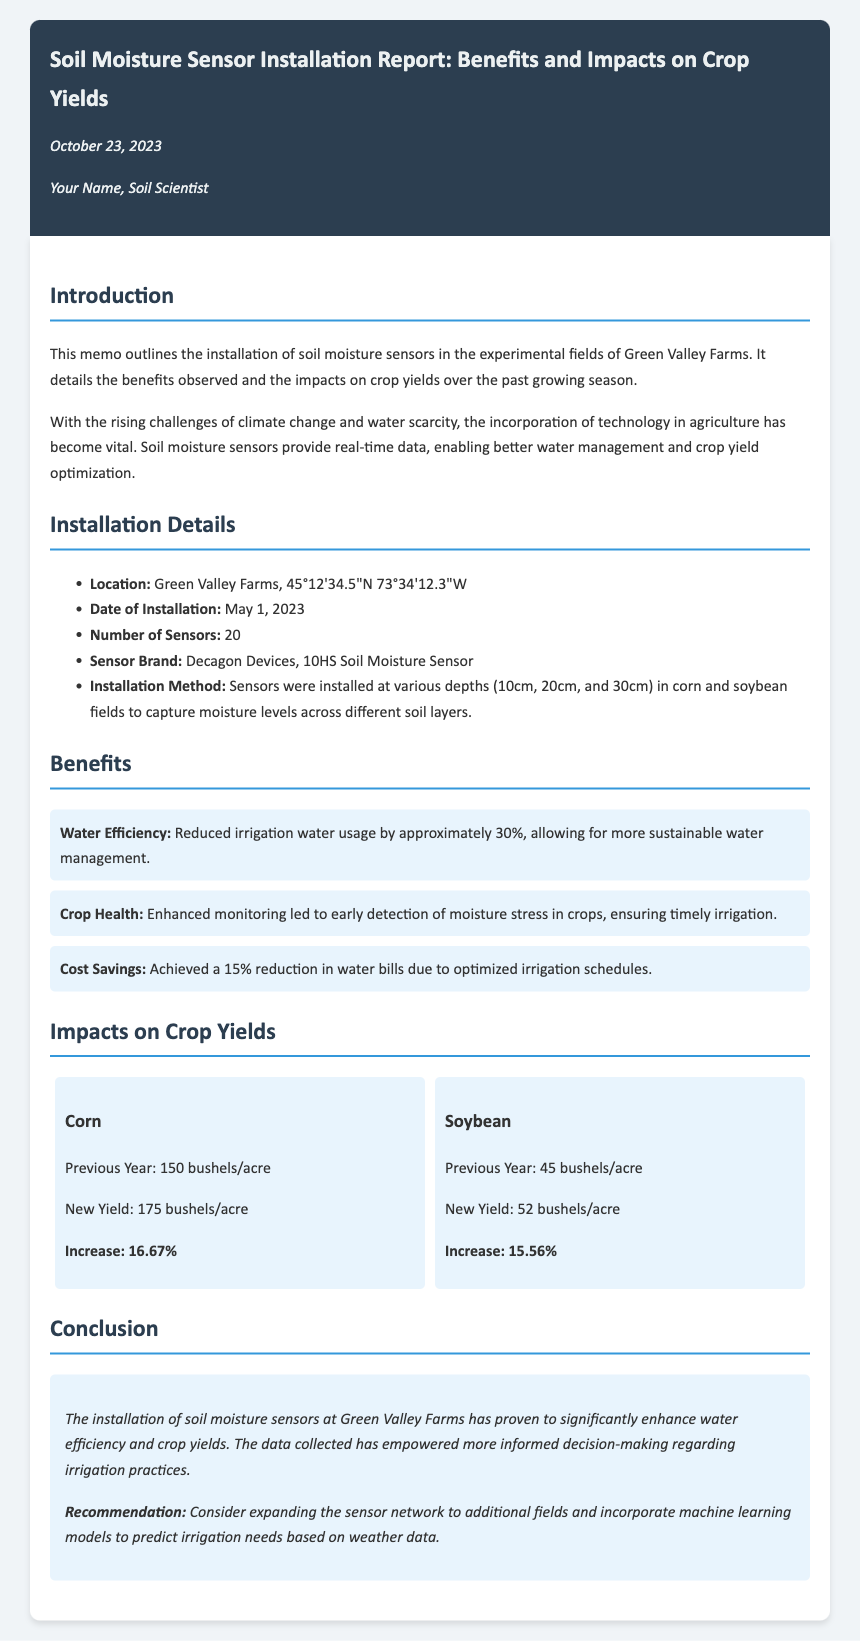What is the installation date of the sensors? The installation date is explicitly mentioned in the document as May 1, 2023.
Answer: May 1, 2023 How many sensors were installed? The document provides the number of sensors installed, which is stated as 20.
Answer: 20 What was the increase in corn yield? The increase in corn yield is noted in the document as 16.67%.
Answer: 16.67% What benefit resulted in cost savings? The document specifies that a 15% reduction in water bills resulted from optimized irrigation schedules.
Answer: 15% What brand of soil moisture sensors was used? The memo mentions Decagon Devices as the brand of the soil moisture sensors used.
Answer: Decagon Devices What was the previous soybean yield? The previous soybean yield is stated in the document as 45 bushels per acre.
Answer: 45 bushels/acre What is a recommended action based on the findings? The document recommends considering expanding the sensor network to additional fields.
Answer: Expanding the sensor network What percentage reduction in irrigation water usage was observed? The memo states that irrigation water usage was reduced by approximately 30%.
Answer: 30% What is the new corn yield reported? The document lists the new corn yield as 175 bushels per acre.
Answer: 175 bushels/acre 